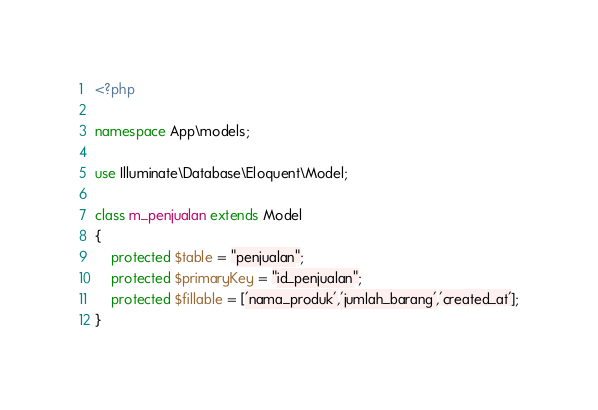<code> <loc_0><loc_0><loc_500><loc_500><_PHP_><?php

namespace App\models;

use Illuminate\Database\Eloquent\Model;

class m_penjualan extends Model
{
    protected $table = "penjualan";
    protected $primaryKey = "id_penjualan";
    protected $fillable = ['nama_produk','jumlah_barang','created_at'];
}
</code> 